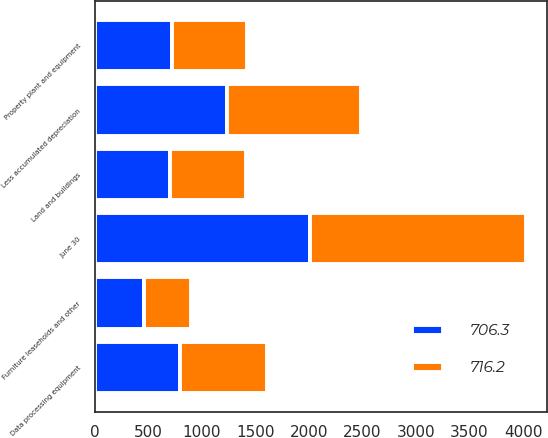<chart> <loc_0><loc_0><loc_500><loc_500><stacked_bar_chart><ecel><fcel>June 30<fcel>Land and buildings<fcel>Data processing equipment<fcel>Furniture leaseholds and other<fcel>Less accumulated depreciation<fcel>Property plant and equipment<nl><fcel>716.2<fcel>2012<fcel>710.4<fcel>815.4<fcel>431.6<fcel>1251.1<fcel>706.3<nl><fcel>706.3<fcel>2011<fcel>698.4<fcel>791<fcel>462.3<fcel>1235.5<fcel>716.2<nl></chart> 